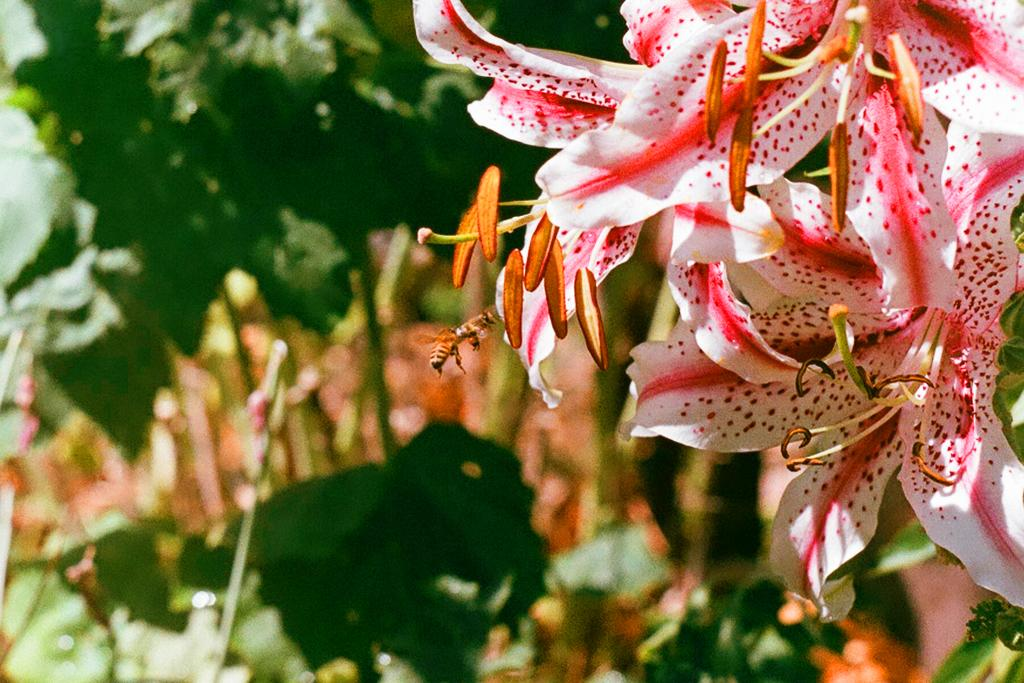What type of vegetation can be seen on the right side of the image? There are flowers on the right side of the image. How would you describe the background of the image? The background has a blurred view. What color is visible in the image? The color green is present in the image. What type of glue is being used by the cook in the image? There is no cook or glue present in the image. What type of trousers is the person wearing in the image? There is no person or trousers present in the image. 